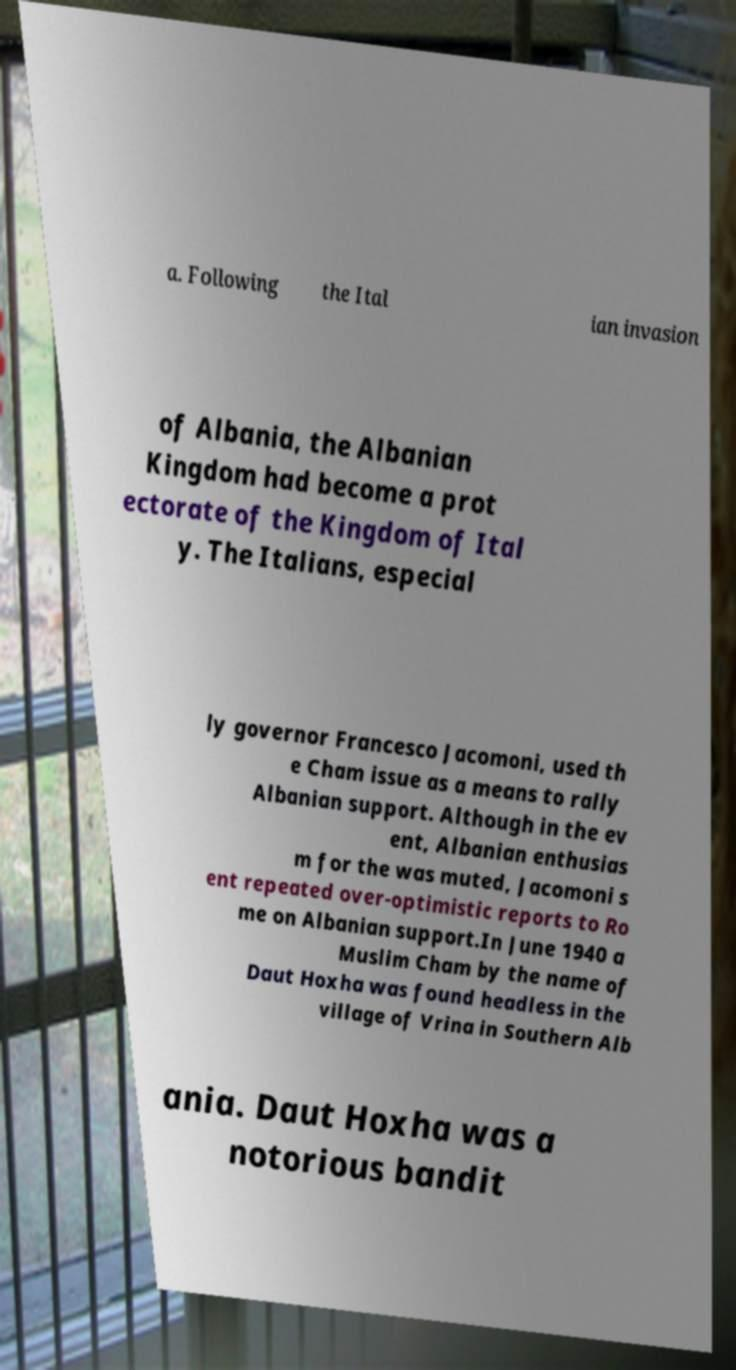I need the written content from this picture converted into text. Can you do that? a. Following the Ital ian invasion of Albania, the Albanian Kingdom had become a prot ectorate of the Kingdom of Ital y. The Italians, especial ly governor Francesco Jacomoni, used th e Cham issue as a means to rally Albanian support. Although in the ev ent, Albanian enthusias m for the was muted, Jacomoni s ent repeated over-optimistic reports to Ro me on Albanian support.In June 1940 a Muslim Cham by the name of Daut Hoxha was found headless in the village of Vrina in Southern Alb ania. Daut Hoxha was a notorious bandit 